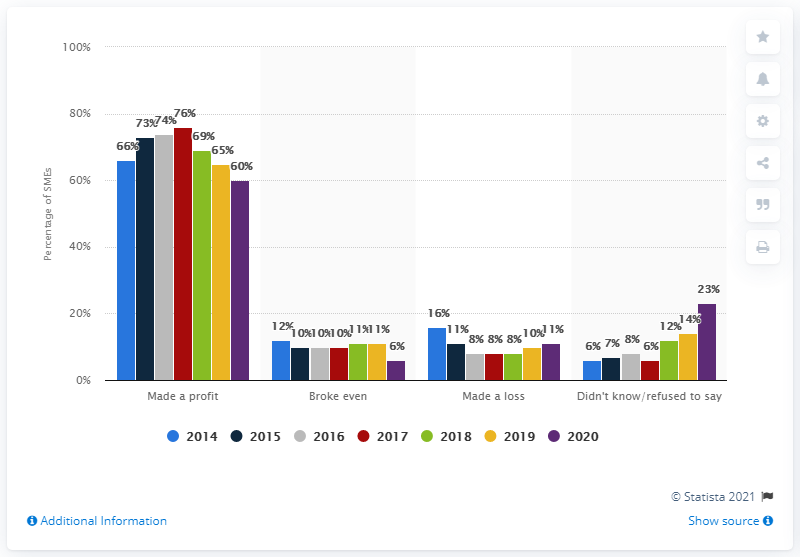Indicate a few pertinent items in this graphic. According to a report by SMEs in June 2020, 60% of them reported making a net profit. 